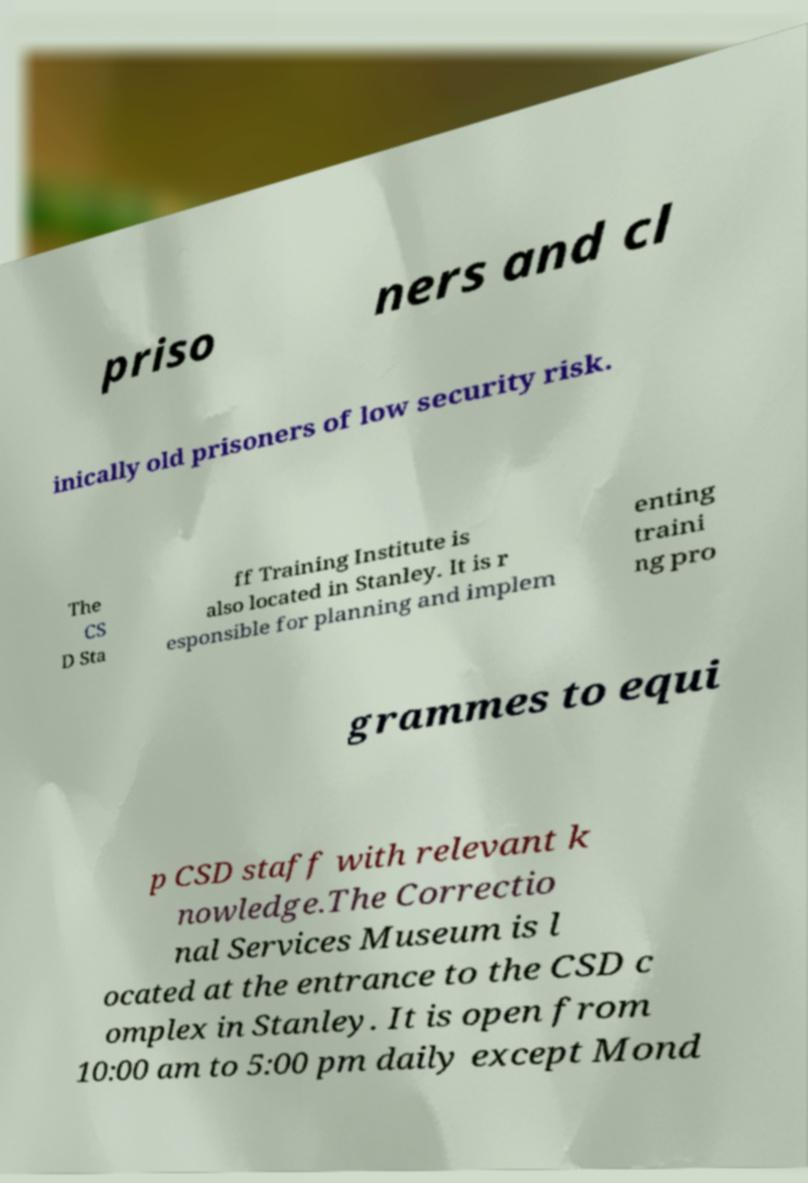I need the written content from this picture converted into text. Can you do that? priso ners and cl inically old prisoners of low security risk. The CS D Sta ff Training Institute is also located in Stanley. It is r esponsible for planning and implem enting traini ng pro grammes to equi p CSD staff with relevant k nowledge.The Correctio nal Services Museum is l ocated at the entrance to the CSD c omplex in Stanley. It is open from 10:00 am to 5:00 pm daily except Mond 